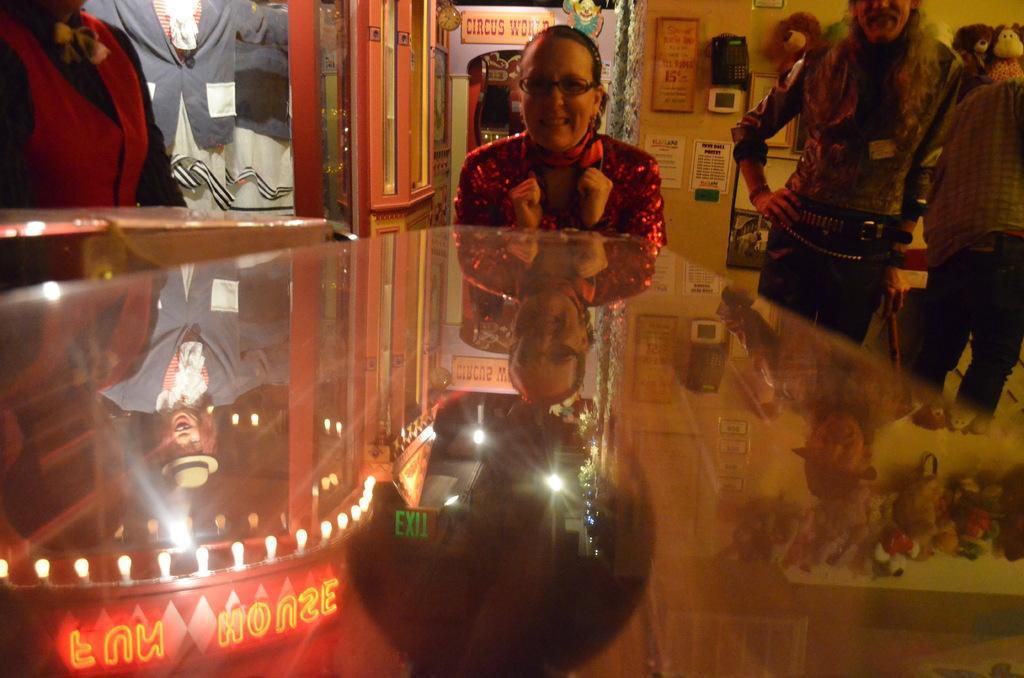How would you summarize this image in a sentence or two? In this picture we can observe a woman smiling, wearing red color dress. She is wearing spectacles. On the right side there are two members standing. On the left side there is a person standing. We can observe a black color ball in this picture. In the background there is a wall and some papers were stuck to the wall. 